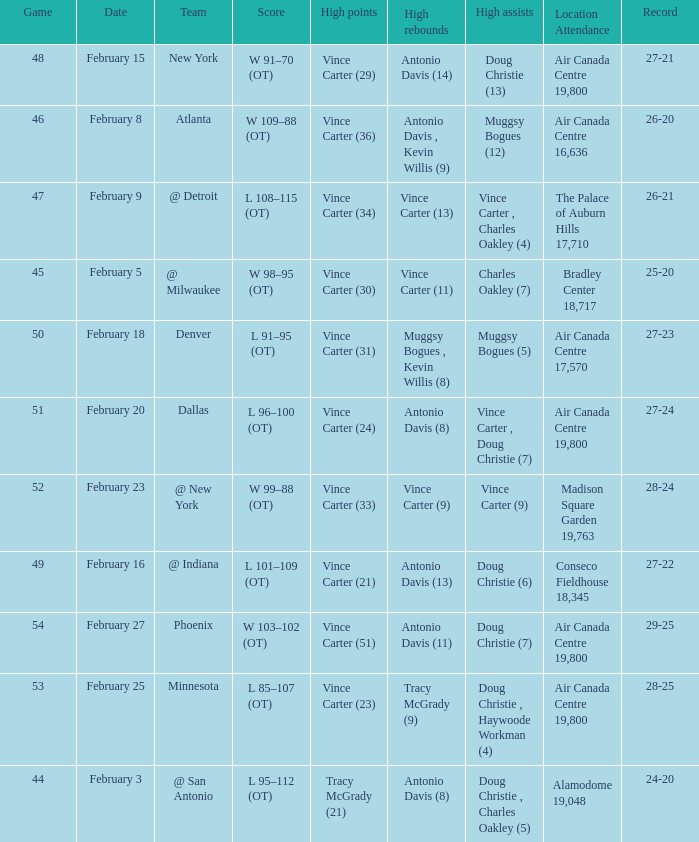Who was the opposing team for game 53? Minnesota. 